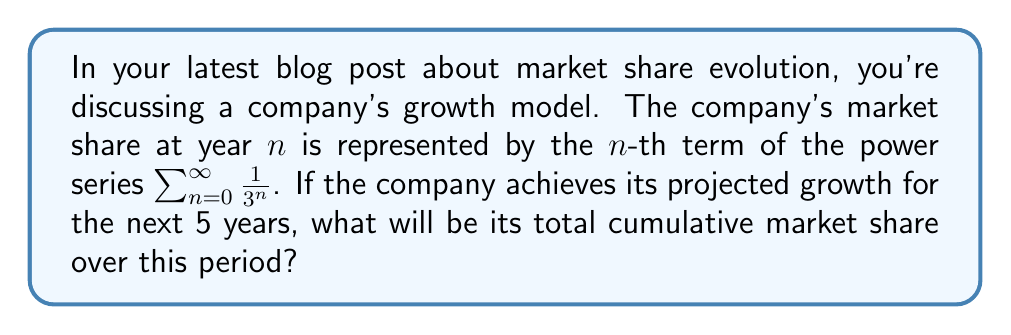Can you solve this math problem? To solve this problem, we need to evaluate the sum of the first 6 terms of the given power series (from n=0 to n=5, inclusive). Let's break it down step-by-step:

1) The series is given by $\sum_{n=0}^{\infty} \frac{1}{3^n}$

2) We need to find $\sum_{n=0}^{5} \frac{1}{3^n}$

3) Let's expand this sum:

   $\frac{1}{3^0} + \frac{1}{3^1} + \frac{1}{3^2} + \frac{1}{3^3} + \frac{1}{3^4} + \frac{1}{3^5}$

4) Simplify:

   $1 + \frac{1}{3} + \frac{1}{9} + \frac{1}{27} + \frac{1}{81} + \frac{1}{243}$

5) We can use the formula for the sum of a geometric series:
   
   $S_n = \frac{a(1-r^n)}{1-r}$, where $a=1$, $r=\frac{1}{3}$, and $n=6$

6) Plugging in these values:

   $S_6 = \frac{1(1-(\frac{1}{3})^6)}{1-\frac{1}{3}} = \frac{1-\frac{1}{729}}{\frac{2}{3}}$

7) Simplify:

   $\frac{728}{729} \cdot \frac{3}{2} = \frac{364}{243}$

Therefore, the total cumulative market share over the 5-year period is $\frac{364}{243}$.
Answer: $\frac{364}{243}$ 